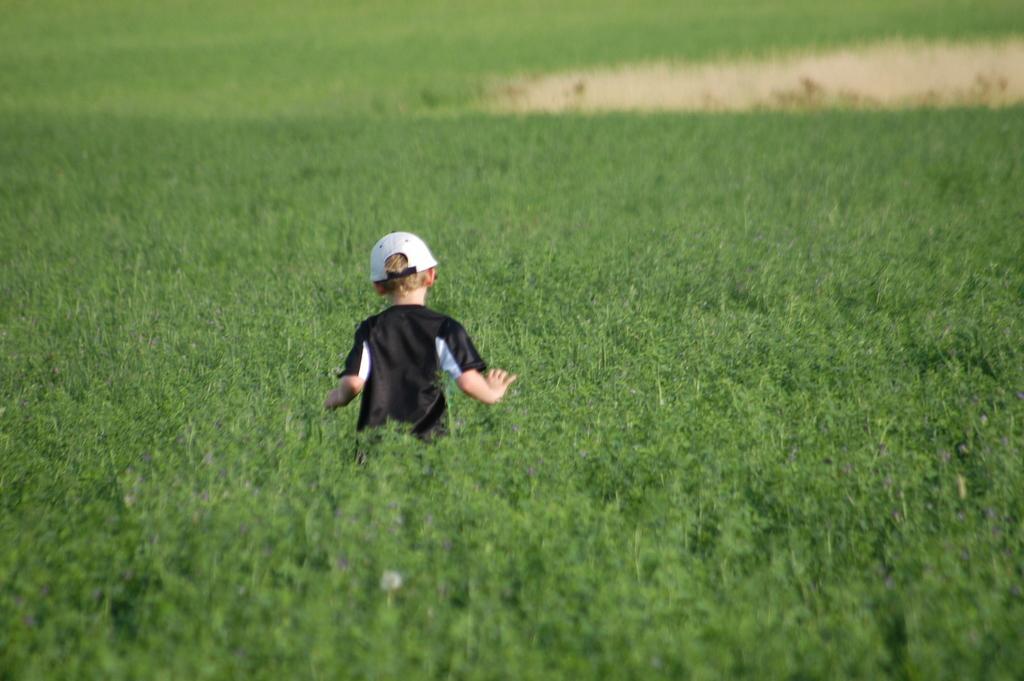Could you give a brief overview of what you see in this image? In this image we can see a boy who is wearing white cap and black t-shirt is in the green color field. 